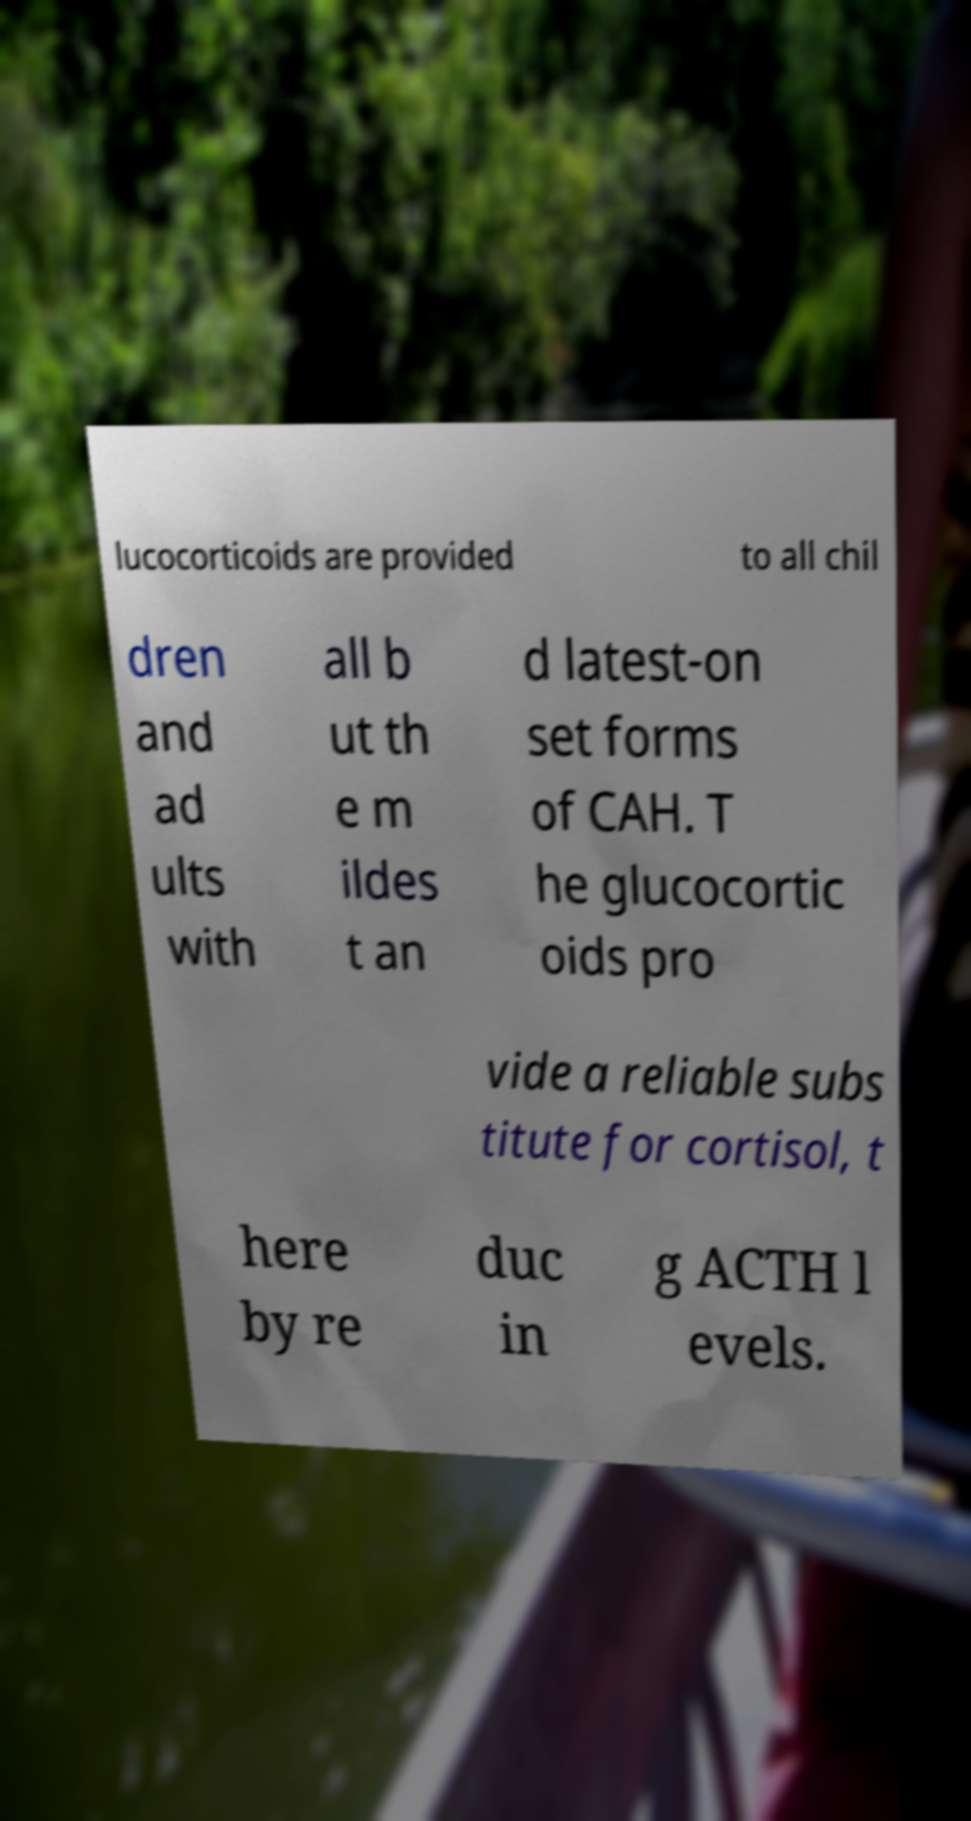I need the written content from this picture converted into text. Can you do that? lucocorticoids are provided to all chil dren and ad ults with all b ut th e m ildes t an d latest-on set forms of CAH. T he glucocortic oids pro vide a reliable subs titute for cortisol, t here by re duc in g ACTH l evels. 